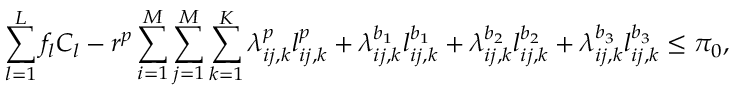Convert formula to latex. <formula><loc_0><loc_0><loc_500><loc_500>\sum _ { l = 1 } ^ { L } f _ { l } C _ { l } - r ^ { p } \sum _ { i = 1 } ^ { M } \sum _ { j = 1 } ^ { M } \sum _ { k = 1 } ^ { K } \lambda _ { i j , k } ^ { p } l _ { i j , k } ^ { p } + \lambda _ { i j , k } ^ { b _ { 1 } } l _ { i j , k } ^ { b _ { 1 } } + \lambda _ { i j , k } ^ { b _ { 2 } } l _ { i j , k } ^ { b _ { 2 } } + \lambda _ { i j , k } ^ { b _ { 3 } } l _ { i j , k } ^ { b _ { 3 } } \leq \pi _ { 0 } ,</formula> 